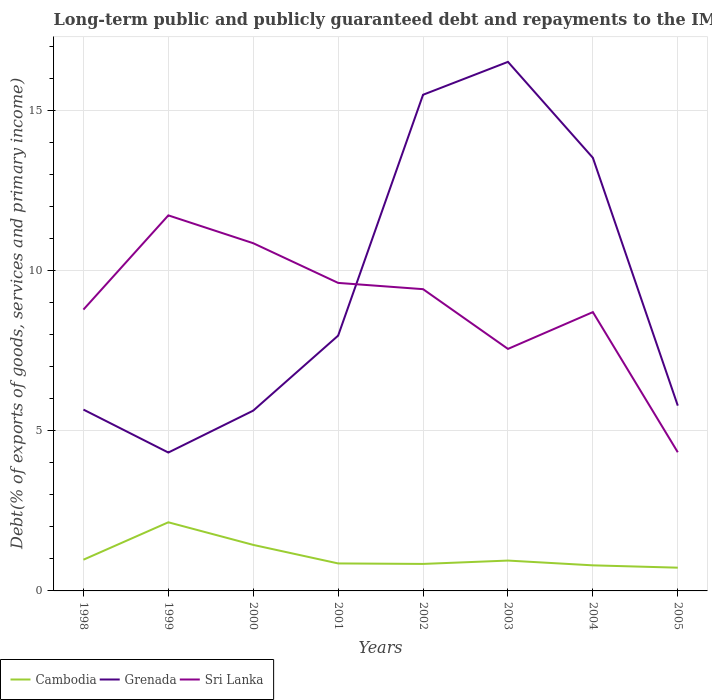Across all years, what is the maximum debt and repayments in Cambodia?
Your response must be concise. 0.73. In which year was the debt and repayments in Cambodia maximum?
Offer a very short reply. 2005. What is the total debt and repayments in Cambodia in the graph?
Provide a succinct answer. 0.13. What is the difference between the highest and the second highest debt and repayments in Grenada?
Provide a short and direct response. 12.19. How many years are there in the graph?
Offer a very short reply. 8. Are the values on the major ticks of Y-axis written in scientific E-notation?
Keep it short and to the point. No. Does the graph contain grids?
Your response must be concise. Yes. Where does the legend appear in the graph?
Your response must be concise. Bottom left. How are the legend labels stacked?
Offer a very short reply. Horizontal. What is the title of the graph?
Your answer should be very brief. Long-term public and publicly guaranteed debt and repayments to the IMF. What is the label or title of the Y-axis?
Provide a short and direct response. Debt(% of exports of goods, services and primary income). What is the Debt(% of exports of goods, services and primary income) of Cambodia in 1998?
Offer a terse response. 0.97. What is the Debt(% of exports of goods, services and primary income) of Grenada in 1998?
Give a very brief answer. 5.66. What is the Debt(% of exports of goods, services and primary income) in Sri Lanka in 1998?
Offer a terse response. 8.78. What is the Debt(% of exports of goods, services and primary income) in Cambodia in 1999?
Your response must be concise. 2.14. What is the Debt(% of exports of goods, services and primary income) in Grenada in 1999?
Your answer should be very brief. 4.32. What is the Debt(% of exports of goods, services and primary income) of Sri Lanka in 1999?
Keep it short and to the point. 11.72. What is the Debt(% of exports of goods, services and primary income) of Cambodia in 2000?
Make the answer very short. 1.44. What is the Debt(% of exports of goods, services and primary income) in Grenada in 2000?
Give a very brief answer. 5.63. What is the Debt(% of exports of goods, services and primary income) of Sri Lanka in 2000?
Provide a succinct answer. 10.85. What is the Debt(% of exports of goods, services and primary income) of Cambodia in 2001?
Offer a very short reply. 0.86. What is the Debt(% of exports of goods, services and primary income) of Grenada in 2001?
Provide a short and direct response. 7.97. What is the Debt(% of exports of goods, services and primary income) of Sri Lanka in 2001?
Your answer should be compact. 9.61. What is the Debt(% of exports of goods, services and primary income) of Cambodia in 2002?
Keep it short and to the point. 0.84. What is the Debt(% of exports of goods, services and primary income) in Grenada in 2002?
Give a very brief answer. 15.49. What is the Debt(% of exports of goods, services and primary income) of Sri Lanka in 2002?
Provide a succinct answer. 9.42. What is the Debt(% of exports of goods, services and primary income) in Cambodia in 2003?
Your answer should be very brief. 0.95. What is the Debt(% of exports of goods, services and primary income) in Grenada in 2003?
Offer a terse response. 16.51. What is the Debt(% of exports of goods, services and primary income) in Sri Lanka in 2003?
Your response must be concise. 7.55. What is the Debt(% of exports of goods, services and primary income) in Cambodia in 2004?
Give a very brief answer. 0.8. What is the Debt(% of exports of goods, services and primary income) of Grenada in 2004?
Provide a succinct answer. 13.52. What is the Debt(% of exports of goods, services and primary income) of Sri Lanka in 2004?
Provide a succinct answer. 8.7. What is the Debt(% of exports of goods, services and primary income) in Cambodia in 2005?
Your response must be concise. 0.73. What is the Debt(% of exports of goods, services and primary income) of Grenada in 2005?
Provide a short and direct response. 5.78. What is the Debt(% of exports of goods, services and primary income) of Sri Lanka in 2005?
Offer a very short reply. 4.33. Across all years, what is the maximum Debt(% of exports of goods, services and primary income) of Cambodia?
Make the answer very short. 2.14. Across all years, what is the maximum Debt(% of exports of goods, services and primary income) of Grenada?
Offer a terse response. 16.51. Across all years, what is the maximum Debt(% of exports of goods, services and primary income) in Sri Lanka?
Offer a terse response. 11.72. Across all years, what is the minimum Debt(% of exports of goods, services and primary income) in Cambodia?
Offer a very short reply. 0.73. Across all years, what is the minimum Debt(% of exports of goods, services and primary income) of Grenada?
Your answer should be very brief. 4.32. Across all years, what is the minimum Debt(% of exports of goods, services and primary income) in Sri Lanka?
Offer a terse response. 4.33. What is the total Debt(% of exports of goods, services and primary income) of Cambodia in the graph?
Provide a succinct answer. 8.72. What is the total Debt(% of exports of goods, services and primary income) in Grenada in the graph?
Make the answer very short. 74.87. What is the total Debt(% of exports of goods, services and primary income) in Sri Lanka in the graph?
Your response must be concise. 70.97. What is the difference between the Debt(% of exports of goods, services and primary income) of Cambodia in 1998 and that in 1999?
Your response must be concise. -1.17. What is the difference between the Debt(% of exports of goods, services and primary income) in Grenada in 1998 and that in 1999?
Provide a succinct answer. 1.34. What is the difference between the Debt(% of exports of goods, services and primary income) of Sri Lanka in 1998 and that in 1999?
Offer a very short reply. -2.94. What is the difference between the Debt(% of exports of goods, services and primary income) of Cambodia in 1998 and that in 2000?
Keep it short and to the point. -0.46. What is the difference between the Debt(% of exports of goods, services and primary income) in Grenada in 1998 and that in 2000?
Keep it short and to the point. 0.03. What is the difference between the Debt(% of exports of goods, services and primary income) of Sri Lanka in 1998 and that in 2000?
Keep it short and to the point. -2.07. What is the difference between the Debt(% of exports of goods, services and primary income) of Cambodia in 1998 and that in 2001?
Give a very brief answer. 0.12. What is the difference between the Debt(% of exports of goods, services and primary income) of Grenada in 1998 and that in 2001?
Give a very brief answer. -2.31. What is the difference between the Debt(% of exports of goods, services and primary income) in Sri Lanka in 1998 and that in 2001?
Your response must be concise. -0.83. What is the difference between the Debt(% of exports of goods, services and primary income) in Cambodia in 1998 and that in 2002?
Your response must be concise. 0.13. What is the difference between the Debt(% of exports of goods, services and primary income) of Grenada in 1998 and that in 2002?
Offer a terse response. -9.83. What is the difference between the Debt(% of exports of goods, services and primary income) of Sri Lanka in 1998 and that in 2002?
Offer a terse response. -0.64. What is the difference between the Debt(% of exports of goods, services and primary income) of Cambodia in 1998 and that in 2003?
Your response must be concise. 0.03. What is the difference between the Debt(% of exports of goods, services and primary income) in Grenada in 1998 and that in 2003?
Provide a short and direct response. -10.85. What is the difference between the Debt(% of exports of goods, services and primary income) of Sri Lanka in 1998 and that in 2003?
Your response must be concise. 1.23. What is the difference between the Debt(% of exports of goods, services and primary income) in Cambodia in 1998 and that in 2004?
Give a very brief answer. 0.18. What is the difference between the Debt(% of exports of goods, services and primary income) in Grenada in 1998 and that in 2004?
Your response must be concise. -7.86. What is the difference between the Debt(% of exports of goods, services and primary income) in Sri Lanka in 1998 and that in 2004?
Provide a short and direct response. 0.08. What is the difference between the Debt(% of exports of goods, services and primary income) in Cambodia in 1998 and that in 2005?
Provide a succinct answer. 0.25. What is the difference between the Debt(% of exports of goods, services and primary income) of Grenada in 1998 and that in 2005?
Your answer should be compact. -0.12. What is the difference between the Debt(% of exports of goods, services and primary income) of Sri Lanka in 1998 and that in 2005?
Provide a short and direct response. 4.45. What is the difference between the Debt(% of exports of goods, services and primary income) in Cambodia in 1999 and that in 2000?
Your answer should be compact. 0.71. What is the difference between the Debt(% of exports of goods, services and primary income) in Grenada in 1999 and that in 2000?
Offer a very short reply. -1.31. What is the difference between the Debt(% of exports of goods, services and primary income) of Sri Lanka in 1999 and that in 2000?
Offer a very short reply. 0.87. What is the difference between the Debt(% of exports of goods, services and primary income) of Cambodia in 1999 and that in 2001?
Keep it short and to the point. 1.28. What is the difference between the Debt(% of exports of goods, services and primary income) in Grenada in 1999 and that in 2001?
Your answer should be very brief. -3.65. What is the difference between the Debt(% of exports of goods, services and primary income) in Sri Lanka in 1999 and that in 2001?
Your answer should be very brief. 2.11. What is the difference between the Debt(% of exports of goods, services and primary income) of Cambodia in 1999 and that in 2002?
Your answer should be compact. 1.3. What is the difference between the Debt(% of exports of goods, services and primary income) in Grenada in 1999 and that in 2002?
Your answer should be very brief. -11.17. What is the difference between the Debt(% of exports of goods, services and primary income) in Sri Lanka in 1999 and that in 2002?
Ensure brevity in your answer.  2.3. What is the difference between the Debt(% of exports of goods, services and primary income) in Cambodia in 1999 and that in 2003?
Keep it short and to the point. 1.19. What is the difference between the Debt(% of exports of goods, services and primary income) in Grenada in 1999 and that in 2003?
Your response must be concise. -12.19. What is the difference between the Debt(% of exports of goods, services and primary income) in Sri Lanka in 1999 and that in 2003?
Provide a succinct answer. 4.17. What is the difference between the Debt(% of exports of goods, services and primary income) of Cambodia in 1999 and that in 2004?
Make the answer very short. 1.34. What is the difference between the Debt(% of exports of goods, services and primary income) in Grenada in 1999 and that in 2004?
Provide a short and direct response. -9.2. What is the difference between the Debt(% of exports of goods, services and primary income) of Sri Lanka in 1999 and that in 2004?
Ensure brevity in your answer.  3.02. What is the difference between the Debt(% of exports of goods, services and primary income) in Cambodia in 1999 and that in 2005?
Keep it short and to the point. 1.42. What is the difference between the Debt(% of exports of goods, services and primary income) in Grenada in 1999 and that in 2005?
Offer a terse response. -1.46. What is the difference between the Debt(% of exports of goods, services and primary income) of Sri Lanka in 1999 and that in 2005?
Offer a terse response. 7.39. What is the difference between the Debt(% of exports of goods, services and primary income) in Cambodia in 2000 and that in 2001?
Provide a short and direct response. 0.58. What is the difference between the Debt(% of exports of goods, services and primary income) of Grenada in 2000 and that in 2001?
Ensure brevity in your answer.  -2.34. What is the difference between the Debt(% of exports of goods, services and primary income) in Sri Lanka in 2000 and that in 2001?
Give a very brief answer. 1.24. What is the difference between the Debt(% of exports of goods, services and primary income) of Cambodia in 2000 and that in 2002?
Provide a short and direct response. 0.59. What is the difference between the Debt(% of exports of goods, services and primary income) of Grenada in 2000 and that in 2002?
Offer a terse response. -9.86. What is the difference between the Debt(% of exports of goods, services and primary income) of Sri Lanka in 2000 and that in 2002?
Your answer should be compact. 1.43. What is the difference between the Debt(% of exports of goods, services and primary income) in Cambodia in 2000 and that in 2003?
Ensure brevity in your answer.  0.49. What is the difference between the Debt(% of exports of goods, services and primary income) in Grenada in 2000 and that in 2003?
Your answer should be very brief. -10.88. What is the difference between the Debt(% of exports of goods, services and primary income) of Sri Lanka in 2000 and that in 2003?
Make the answer very short. 3.3. What is the difference between the Debt(% of exports of goods, services and primary income) in Cambodia in 2000 and that in 2004?
Your response must be concise. 0.64. What is the difference between the Debt(% of exports of goods, services and primary income) of Grenada in 2000 and that in 2004?
Make the answer very short. -7.89. What is the difference between the Debt(% of exports of goods, services and primary income) in Sri Lanka in 2000 and that in 2004?
Ensure brevity in your answer.  2.15. What is the difference between the Debt(% of exports of goods, services and primary income) in Cambodia in 2000 and that in 2005?
Provide a short and direct response. 0.71. What is the difference between the Debt(% of exports of goods, services and primary income) of Grenada in 2000 and that in 2005?
Offer a terse response. -0.16. What is the difference between the Debt(% of exports of goods, services and primary income) of Sri Lanka in 2000 and that in 2005?
Offer a very short reply. 6.52. What is the difference between the Debt(% of exports of goods, services and primary income) of Cambodia in 2001 and that in 2002?
Provide a succinct answer. 0.02. What is the difference between the Debt(% of exports of goods, services and primary income) of Grenada in 2001 and that in 2002?
Your answer should be very brief. -7.52. What is the difference between the Debt(% of exports of goods, services and primary income) in Sri Lanka in 2001 and that in 2002?
Your response must be concise. 0.2. What is the difference between the Debt(% of exports of goods, services and primary income) in Cambodia in 2001 and that in 2003?
Your answer should be very brief. -0.09. What is the difference between the Debt(% of exports of goods, services and primary income) of Grenada in 2001 and that in 2003?
Your answer should be compact. -8.54. What is the difference between the Debt(% of exports of goods, services and primary income) in Sri Lanka in 2001 and that in 2003?
Keep it short and to the point. 2.06. What is the difference between the Debt(% of exports of goods, services and primary income) in Cambodia in 2001 and that in 2004?
Your response must be concise. 0.06. What is the difference between the Debt(% of exports of goods, services and primary income) of Grenada in 2001 and that in 2004?
Offer a very short reply. -5.55. What is the difference between the Debt(% of exports of goods, services and primary income) of Sri Lanka in 2001 and that in 2004?
Make the answer very short. 0.91. What is the difference between the Debt(% of exports of goods, services and primary income) in Cambodia in 2001 and that in 2005?
Your answer should be compact. 0.13. What is the difference between the Debt(% of exports of goods, services and primary income) of Grenada in 2001 and that in 2005?
Offer a terse response. 2.19. What is the difference between the Debt(% of exports of goods, services and primary income) in Sri Lanka in 2001 and that in 2005?
Provide a succinct answer. 5.29. What is the difference between the Debt(% of exports of goods, services and primary income) of Cambodia in 2002 and that in 2003?
Keep it short and to the point. -0.1. What is the difference between the Debt(% of exports of goods, services and primary income) in Grenada in 2002 and that in 2003?
Your answer should be very brief. -1.03. What is the difference between the Debt(% of exports of goods, services and primary income) in Sri Lanka in 2002 and that in 2003?
Ensure brevity in your answer.  1.86. What is the difference between the Debt(% of exports of goods, services and primary income) in Cambodia in 2002 and that in 2004?
Provide a succinct answer. 0.04. What is the difference between the Debt(% of exports of goods, services and primary income) of Grenada in 2002 and that in 2004?
Offer a very short reply. 1.97. What is the difference between the Debt(% of exports of goods, services and primary income) of Sri Lanka in 2002 and that in 2004?
Provide a short and direct response. 0.72. What is the difference between the Debt(% of exports of goods, services and primary income) in Cambodia in 2002 and that in 2005?
Offer a very short reply. 0.12. What is the difference between the Debt(% of exports of goods, services and primary income) in Grenada in 2002 and that in 2005?
Ensure brevity in your answer.  9.7. What is the difference between the Debt(% of exports of goods, services and primary income) in Sri Lanka in 2002 and that in 2005?
Your answer should be compact. 5.09. What is the difference between the Debt(% of exports of goods, services and primary income) in Cambodia in 2003 and that in 2004?
Your answer should be compact. 0.15. What is the difference between the Debt(% of exports of goods, services and primary income) in Grenada in 2003 and that in 2004?
Give a very brief answer. 2.99. What is the difference between the Debt(% of exports of goods, services and primary income) of Sri Lanka in 2003 and that in 2004?
Make the answer very short. -1.15. What is the difference between the Debt(% of exports of goods, services and primary income) of Cambodia in 2003 and that in 2005?
Offer a terse response. 0.22. What is the difference between the Debt(% of exports of goods, services and primary income) in Grenada in 2003 and that in 2005?
Your answer should be very brief. 10.73. What is the difference between the Debt(% of exports of goods, services and primary income) of Sri Lanka in 2003 and that in 2005?
Offer a very short reply. 3.23. What is the difference between the Debt(% of exports of goods, services and primary income) in Cambodia in 2004 and that in 2005?
Make the answer very short. 0.07. What is the difference between the Debt(% of exports of goods, services and primary income) in Grenada in 2004 and that in 2005?
Ensure brevity in your answer.  7.74. What is the difference between the Debt(% of exports of goods, services and primary income) in Sri Lanka in 2004 and that in 2005?
Your answer should be very brief. 4.37. What is the difference between the Debt(% of exports of goods, services and primary income) in Cambodia in 1998 and the Debt(% of exports of goods, services and primary income) in Grenada in 1999?
Provide a short and direct response. -3.34. What is the difference between the Debt(% of exports of goods, services and primary income) of Cambodia in 1998 and the Debt(% of exports of goods, services and primary income) of Sri Lanka in 1999?
Make the answer very short. -10.75. What is the difference between the Debt(% of exports of goods, services and primary income) in Grenada in 1998 and the Debt(% of exports of goods, services and primary income) in Sri Lanka in 1999?
Keep it short and to the point. -6.06. What is the difference between the Debt(% of exports of goods, services and primary income) in Cambodia in 1998 and the Debt(% of exports of goods, services and primary income) in Grenada in 2000?
Your response must be concise. -4.65. What is the difference between the Debt(% of exports of goods, services and primary income) in Cambodia in 1998 and the Debt(% of exports of goods, services and primary income) in Sri Lanka in 2000?
Offer a terse response. -9.88. What is the difference between the Debt(% of exports of goods, services and primary income) of Grenada in 1998 and the Debt(% of exports of goods, services and primary income) of Sri Lanka in 2000?
Offer a very short reply. -5.19. What is the difference between the Debt(% of exports of goods, services and primary income) of Cambodia in 1998 and the Debt(% of exports of goods, services and primary income) of Grenada in 2001?
Provide a succinct answer. -6.99. What is the difference between the Debt(% of exports of goods, services and primary income) in Cambodia in 1998 and the Debt(% of exports of goods, services and primary income) in Sri Lanka in 2001?
Make the answer very short. -8.64. What is the difference between the Debt(% of exports of goods, services and primary income) of Grenada in 1998 and the Debt(% of exports of goods, services and primary income) of Sri Lanka in 2001?
Offer a very short reply. -3.95. What is the difference between the Debt(% of exports of goods, services and primary income) of Cambodia in 1998 and the Debt(% of exports of goods, services and primary income) of Grenada in 2002?
Offer a very short reply. -14.51. What is the difference between the Debt(% of exports of goods, services and primary income) in Cambodia in 1998 and the Debt(% of exports of goods, services and primary income) in Sri Lanka in 2002?
Your answer should be compact. -8.44. What is the difference between the Debt(% of exports of goods, services and primary income) in Grenada in 1998 and the Debt(% of exports of goods, services and primary income) in Sri Lanka in 2002?
Keep it short and to the point. -3.76. What is the difference between the Debt(% of exports of goods, services and primary income) in Cambodia in 1998 and the Debt(% of exports of goods, services and primary income) in Grenada in 2003?
Offer a terse response. -15.54. What is the difference between the Debt(% of exports of goods, services and primary income) in Cambodia in 1998 and the Debt(% of exports of goods, services and primary income) in Sri Lanka in 2003?
Keep it short and to the point. -6.58. What is the difference between the Debt(% of exports of goods, services and primary income) of Grenada in 1998 and the Debt(% of exports of goods, services and primary income) of Sri Lanka in 2003?
Provide a succinct answer. -1.89. What is the difference between the Debt(% of exports of goods, services and primary income) in Cambodia in 1998 and the Debt(% of exports of goods, services and primary income) in Grenada in 2004?
Your answer should be compact. -12.54. What is the difference between the Debt(% of exports of goods, services and primary income) in Cambodia in 1998 and the Debt(% of exports of goods, services and primary income) in Sri Lanka in 2004?
Your answer should be very brief. -7.73. What is the difference between the Debt(% of exports of goods, services and primary income) of Grenada in 1998 and the Debt(% of exports of goods, services and primary income) of Sri Lanka in 2004?
Your answer should be very brief. -3.04. What is the difference between the Debt(% of exports of goods, services and primary income) in Cambodia in 1998 and the Debt(% of exports of goods, services and primary income) in Grenada in 2005?
Your answer should be compact. -4.81. What is the difference between the Debt(% of exports of goods, services and primary income) of Cambodia in 1998 and the Debt(% of exports of goods, services and primary income) of Sri Lanka in 2005?
Your answer should be very brief. -3.35. What is the difference between the Debt(% of exports of goods, services and primary income) of Grenada in 1998 and the Debt(% of exports of goods, services and primary income) of Sri Lanka in 2005?
Your answer should be compact. 1.33. What is the difference between the Debt(% of exports of goods, services and primary income) in Cambodia in 1999 and the Debt(% of exports of goods, services and primary income) in Grenada in 2000?
Make the answer very short. -3.49. What is the difference between the Debt(% of exports of goods, services and primary income) of Cambodia in 1999 and the Debt(% of exports of goods, services and primary income) of Sri Lanka in 2000?
Provide a short and direct response. -8.71. What is the difference between the Debt(% of exports of goods, services and primary income) in Grenada in 1999 and the Debt(% of exports of goods, services and primary income) in Sri Lanka in 2000?
Ensure brevity in your answer.  -6.53. What is the difference between the Debt(% of exports of goods, services and primary income) in Cambodia in 1999 and the Debt(% of exports of goods, services and primary income) in Grenada in 2001?
Your response must be concise. -5.83. What is the difference between the Debt(% of exports of goods, services and primary income) of Cambodia in 1999 and the Debt(% of exports of goods, services and primary income) of Sri Lanka in 2001?
Ensure brevity in your answer.  -7.47. What is the difference between the Debt(% of exports of goods, services and primary income) of Grenada in 1999 and the Debt(% of exports of goods, services and primary income) of Sri Lanka in 2001?
Give a very brief answer. -5.29. What is the difference between the Debt(% of exports of goods, services and primary income) of Cambodia in 1999 and the Debt(% of exports of goods, services and primary income) of Grenada in 2002?
Your answer should be very brief. -13.34. What is the difference between the Debt(% of exports of goods, services and primary income) in Cambodia in 1999 and the Debt(% of exports of goods, services and primary income) in Sri Lanka in 2002?
Make the answer very short. -7.28. What is the difference between the Debt(% of exports of goods, services and primary income) of Grenada in 1999 and the Debt(% of exports of goods, services and primary income) of Sri Lanka in 2002?
Offer a terse response. -5.1. What is the difference between the Debt(% of exports of goods, services and primary income) in Cambodia in 1999 and the Debt(% of exports of goods, services and primary income) in Grenada in 2003?
Offer a terse response. -14.37. What is the difference between the Debt(% of exports of goods, services and primary income) in Cambodia in 1999 and the Debt(% of exports of goods, services and primary income) in Sri Lanka in 2003?
Your answer should be very brief. -5.41. What is the difference between the Debt(% of exports of goods, services and primary income) of Grenada in 1999 and the Debt(% of exports of goods, services and primary income) of Sri Lanka in 2003?
Make the answer very short. -3.23. What is the difference between the Debt(% of exports of goods, services and primary income) of Cambodia in 1999 and the Debt(% of exports of goods, services and primary income) of Grenada in 2004?
Give a very brief answer. -11.38. What is the difference between the Debt(% of exports of goods, services and primary income) of Cambodia in 1999 and the Debt(% of exports of goods, services and primary income) of Sri Lanka in 2004?
Your response must be concise. -6.56. What is the difference between the Debt(% of exports of goods, services and primary income) in Grenada in 1999 and the Debt(% of exports of goods, services and primary income) in Sri Lanka in 2004?
Your answer should be very brief. -4.38. What is the difference between the Debt(% of exports of goods, services and primary income) in Cambodia in 1999 and the Debt(% of exports of goods, services and primary income) in Grenada in 2005?
Give a very brief answer. -3.64. What is the difference between the Debt(% of exports of goods, services and primary income) in Cambodia in 1999 and the Debt(% of exports of goods, services and primary income) in Sri Lanka in 2005?
Your answer should be very brief. -2.19. What is the difference between the Debt(% of exports of goods, services and primary income) of Grenada in 1999 and the Debt(% of exports of goods, services and primary income) of Sri Lanka in 2005?
Give a very brief answer. -0.01. What is the difference between the Debt(% of exports of goods, services and primary income) in Cambodia in 2000 and the Debt(% of exports of goods, services and primary income) in Grenada in 2001?
Provide a short and direct response. -6.53. What is the difference between the Debt(% of exports of goods, services and primary income) in Cambodia in 2000 and the Debt(% of exports of goods, services and primary income) in Sri Lanka in 2001?
Your response must be concise. -8.18. What is the difference between the Debt(% of exports of goods, services and primary income) in Grenada in 2000 and the Debt(% of exports of goods, services and primary income) in Sri Lanka in 2001?
Offer a terse response. -3.99. What is the difference between the Debt(% of exports of goods, services and primary income) in Cambodia in 2000 and the Debt(% of exports of goods, services and primary income) in Grenada in 2002?
Offer a very short reply. -14.05. What is the difference between the Debt(% of exports of goods, services and primary income) of Cambodia in 2000 and the Debt(% of exports of goods, services and primary income) of Sri Lanka in 2002?
Your response must be concise. -7.98. What is the difference between the Debt(% of exports of goods, services and primary income) of Grenada in 2000 and the Debt(% of exports of goods, services and primary income) of Sri Lanka in 2002?
Your answer should be compact. -3.79. What is the difference between the Debt(% of exports of goods, services and primary income) in Cambodia in 2000 and the Debt(% of exports of goods, services and primary income) in Grenada in 2003?
Make the answer very short. -15.08. What is the difference between the Debt(% of exports of goods, services and primary income) in Cambodia in 2000 and the Debt(% of exports of goods, services and primary income) in Sri Lanka in 2003?
Offer a terse response. -6.12. What is the difference between the Debt(% of exports of goods, services and primary income) of Grenada in 2000 and the Debt(% of exports of goods, services and primary income) of Sri Lanka in 2003?
Your answer should be compact. -1.93. What is the difference between the Debt(% of exports of goods, services and primary income) of Cambodia in 2000 and the Debt(% of exports of goods, services and primary income) of Grenada in 2004?
Provide a short and direct response. -12.08. What is the difference between the Debt(% of exports of goods, services and primary income) in Cambodia in 2000 and the Debt(% of exports of goods, services and primary income) in Sri Lanka in 2004?
Keep it short and to the point. -7.27. What is the difference between the Debt(% of exports of goods, services and primary income) of Grenada in 2000 and the Debt(% of exports of goods, services and primary income) of Sri Lanka in 2004?
Offer a very short reply. -3.07. What is the difference between the Debt(% of exports of goods, services and primary income) in Cambodia in 2000 and the Debt(% of exports of goods, services and primary income) in Grenada in 2005?
Keep it short and to the point. -4.35. What is the difference between the Debt(% of exports of goods, services and primary income) of Cambodia in 2000 and the Debt(% of exports of goods, services and primary income) of Sri Lanka in 2005?
Offer a very short reply. -2.89. What is the difference between the Debt(% of exports of goods, services and primary income) in Grenada in 2000 and the Debt(% of exports of goods, services and primary income) in Sri Lanka in 2005?
Your answer should be compact. 1.3. What is the difference between the Debt(% of exports of goods, services and primary income) in Cambodia in 2001 and the Debt(% of exports of goods, services and primary income) in Grenada in 2002?
Offer a terse response. -14.63. What is the difference between the Debt(% of exports of goods, services and primary income) of Cambodia in 2001 and the Debt(% of exports of goods, services and primary income) of Sri Lanka in 2002?
Offer a terse response. -8.56. What is the difference between the Debt(% of exports of goods, services and primary income) of Grenada in 2001 and the Debt(% of exports of goods, services and primary income) of Sri Lanka in 2002?
Provide a short and direct response. -1.45. What is the difference between the Debt(% of exports of goods, services and primary income) in Cambodia in 2001 and the Debt(% of exports of goods, services and primary income) in Grenada in 2003?
Offer a terse response. -15.65. What is the difference between the Debt(% of exports of goods, services and primary income) in Cambodia in 2001 and the Debt(% of exports of goods, services and primary income) in Sri Lanka in 2003?
Give a very brief answer. -6.7. What is the difference between the Debt(% of exports of goods, services and primary income) in Grenada in 2001 and the Debt(% of exports of goods, services and primary income) in Sri Lanka in 2003?
Keep it short and to the point. 0.41. What is the difference between the Debt(% of exports of goods, services and primary income) in Cambodia in 2001 and the Debt(% of exports of goods, services and primary income) in Grenada in 2004?
Offer a terse response. -12.66. What is the difference between the Debt(% of exports of goods, services and primary income) in Cambodia in 2001 and the Debt(% of exports of goods, services and primary income) in Sri Lanka in 2004?
Your answer should be compact. -7.84. What is the difference between the Debt(% of exports of goods, services and primary income) of Grenada in 2001 and the Debt(% of exports of goods, services and primary income) of Sri Lanka in 2004?
Make the answer very short. -0.73. What is the difference between the Debt(% of exports of goods, services and primary income) of Cambodia in 2001 and the Debt(% of exports of goods, services and primary income) of Grenada in 2005?
Your answer should be very brief. -4.92. What is the difference between the Debt(% of exports of goods, services and primary income) of Cambodia in 2001 and the Debt(% of exports of goods, services and primary income) of Sri Lanka in 2005?
Make the answer very short. -3.47. What is the difference between the Debt(% of exports of goods, services and primary income) in Grenada in 2001 and the Debt(% of exports of goods, services and primary income) in Sri Lanka in 2005?
Provide a short and direct response. 3.64. What is the difference between the Debt(% of exports of goods, services and primary income) in Cambodia in 2002 and the Debt(% of exports of goods, services and primary income) in Grenada in 2003?
Offer a very short reply. -15.67. What is the difference between the Debt(% of exports of goods, services and primary income) in Cambodia in 2002 and the Debt(% of exports of goods, services and primary income) in Sri Lanka in 2003?
Keep it short and to the point. -6.71. What is the difference between the Debt(% of exports of goods, services and primary income) in Grenada in 2002 and the Debt(% of exports of goods, services and primary income) in Sri Lanka in 2003?
Make the answer very short. 7.93. What is the difference between the Debt(% of exports of goods, services and primary income) of Cambodia in 2002 and the Debt(% of exports of goods, services and primary income) of Grenada in 2004?
Give a very brief answer. -12.68. What is the difference between the Debt(% of exports of goods, services and primary income) in Cambodia in 2002 and the Debt(% of exports of goods, services and primary income) in Sri Lanka in 2004?
Your answer should be compact. -7.86. What is the difference between the Debt(% of exports of goods, services and primary income) in Grenada in 2002 and the Debt(% of exports of goods, services and primary income) in Sri Lanka in 2004?
Offer a terse response. 6.78. What is the difference between the Debt(% of exports of goods, services and primary income) of Cambodia in 2002 and the Debt(% of exports of goods, services and primary income) of Grenada in 2005?
Your response must be concise. -4.94. What is the difference between the Debt(% of exports of goods, services and primary income) of Cambodia in 2002 and the Debt(% of exports of goods, services and primary income) of Sri Lanka in 2005?
Provide a succinct answer. -3.49. What is the difference between the Debt(% of exports of goods, services and primary income) in Grenada in 2002 and the Debt(% of exports of goods, services and primary income) in Sri Lanka in 2005?
Make the answer very short. 11.16. What is the difference between the Debt(% of exports of goods, services and primary income) in Cambodia in 2003 and the Debt(% of exports of goods, services and primary income) in Grenada in 2004?
Provide a succinct answer. -12.57. What is the difference between the Debt(% of exports of goods, services and primary income) of Cambodia in 2003 and the Debt(% of exports of goods, services and primary income) of Sri Lanka in 2004?
Make the answer very short. -7.75. What is the difference between the Debt(% of exports of goods, services and primary income) of Grenada in 2003 and the Debt(% of exports of goods, services and primary income) of Sri Lanka in 2004?
Keep it short and to the point. 7.81. What is the difference between the Debt(% of exports of goods, services and primary income) in Cambodia in 2003 and the Debt(% of exports of goods, services and primary income) in Grenada in 2005?
Make the answer very short. -4.84. What is the difference between the Debt(% of exports of goods, services and primary income) in Cambodia in 2003 and the Debt(% of exports of goods, services and primary income) in Sri Lanka in 2005?
Your answer should be compact. -3.38. What is the difference between the Debt(% of exports of goods, services and primary income) in Grenada in 2003 and the Debt(% of exports of goods, services and primary income) in Sri Lanka in 2005?
Provide a short and direct response. 12.18. What is the difference between the Debt(% of exports of goods, services and primary income) in Cambodia in 2004 and the Debt(% of exports of goods, services and primary income) in Grenada in 2005?
Make the answer very short. -4.98. What is the difference between the Debt(% of exports of goods, services and primary income) in Cambodia in 2004 and the Debt(% of exports of goods, services and primary income) in Sri Lanka in 2005?
Keep it short and to the point. -3.53. What is the difference between the Debt(% of exports of goods, services and primary income) of Grenada in 2004 and the Debt(% of exports of goods, services and primary income) of Sri Lanka in 2005?
Ensure brevity in your answer.  9.19. What is the average Debt(% of exports of goods, services and primary income) of Cambodia per year?
Keep it short and to the point. 1.09. What is the average Debt(% of exports of goods, services and primary income) in Grenada per year?
Offer a very short reply. 9.36. What is the average Debt(% of exports of goods, services and primary income) of Sri Lanka per year?
Offer a terse response. 8.87. In the year 1998, what is the difference between the Debt(% of exports of goods, services and primary income) of Cambodia and Debt(% of exports of goods, services and primary income) of Grenada?
Your answer should be compact. -4.69. In the year 1998, what is the difference between the Debt(% of exports of goods, services and primary income) in Cambodia and Debt(% of exports of goods, services and primary income) in Sri Lanka?
Your response must be concise. -7.81. In the year 1998, what is the difference between the Debt(% of exports of goods, services and primary income) in Grenada and Debt(% of exports of goods, services and primary income) in Sri Lanka?
Ensure brevity in your answer.  -3.12. In the year 1999, what is the difference between the Debt(% of exports of goods, services and primary income) of Cambodia and Debt(% of exports of goods, services and primary income) of Grenada?
Give a very brief answer. -2.18. In the year 1999, what is the difference between the Debt(% of exports of goods, services and primary income) in Cambodia and Debt(% of exports of goods, services and primary income) in Sri Lanka?
Provide a succinct answer. -9.58. In the year 1999, what is the difference between the Debt(% of exports of goods, services and primary income) of Grenada and Debt(% of exports of goods, services and primary income) of Sri Lanka?
Your response must be concise. -7.4. In the year 2000, what is the difference between the Debt(% of exports of goods, services and primary income) of Cambodia and Debt(% of exports of goods, services and primary income) of Grenada?
Your answer should be compact. -4.19. In the year 2000, what is the difference between the Debt(% of exports of goods, services and primary income) of Cambodia and Debt(% of exports of goods, services and primary income) of Sri Lanka?
Ensure brevity in your answer.  -9.42. In the year 2000, what is the difference between the Debt(% of exports of goods, services and primary income) in Grenada and Debt(% of exports of goods, services and primary income) in Sri Lanka?
Ensure brevity in your answer.  -5.22. In the year 2001, what is the difference between the Debt(% of exports of goods, services and primary income) of Cambodia and Debt(% of exports of goods, services and primary income) of Grenada?
Offer a terse response. -7.11. In the year 2001, what is the difference between the Debt(% of exports of goods, services and primary income) in Cambodia and Debt(% of exports of goods, services and primary income) in Sri Lanka?
Offer a terse response. -8.76. In the year 2001, what is the difference between the Debt(% of exports of goods, services and primary income) in Grenada and Debt(% of exports of goods, services and primary income) in Sri Lanka?
Your response must be concise. -1.65. In the year 2002, what is the difference between the Debt(% of exports of goods, services and primary income) of Cambodia and Debt(% of exports of goods, services and primary income) of Grenada?
Your answer should be compact. -14.64. In the year 2002, what is the difference between the Debt(% of exports of goods, services and primary income) in Cambodia and Debt(% of exports of goods, services and primary income) in Sri Lanka?
Provide a succinct answer. -8.58. In the year 2002, what is the difference between the Debt(% of exports of goods, services and primary income) in Grenada and Debt(% of exports of goods, services and primary income) in Sri Lanka?
Ensure brevity in your answer.  6.07. In the year 2003, what is the difference between the Debt(% of exports of goods, services and primary income) of Cambodia and Debt(% of exports of goods, services and primary income) of Grenada?
Keep it short and to the point. -15.56. In the year 2003, what is the difference between the Debt(% of exports of goods, services and primary income) of Cambodia and Debt(% of exports of goods, services and primary income) of Sri Lanka?
Provide a succinct answer. -6.61. In the year 2003, what is the difference between the Debt(% of exports of goods, services and primary income) of Grenada and Debt(% of exports of goods, services and primary income) of Sri Lanka?
Offer a very short reply. 8.96. In the year 2004, what is the difference between the Debt(% of exports of goods, services and primary income) of Cambodia and Debt(% of exports of goods, services and primary income) of Grenada?
Ensure brevity in your answer.  -12.72. In the year 2004, what is the difference between the Debt(% of exports of goods, services and primary income) in Cambodia and Debt(% of exports of goods, services and primary income) in Sri Lanka?
Your answer should be compact. -7.9. In the year 2004, what is the difference between the Debt(% of exports of goods, services and primary income) in Grenada and Debt(% of exports of goods, services and primary income) in Sri Lanka?
Offer a terse response. 4.82. In the year 2005, what is the difference between the Debt(% of exports of goods, services and primary income) in Cambodia and Debt(% of exports of goods, services and primary income) in Grenada?
Ensure brevity in your answer.  -5.06. In the year 2005, what is the difference between the Debt(% of exports of goods, services and primary income) in Cambodia and Debt(% of exports of goods, services and primary income) in Sri Lanka?
Offer a terse response. -3.6. In the year 2005, what is the difference between the Debt(% of exports of goods, services and primary income) of Grenada and Debt(% of exports of goods, services and primary income) of Sri Lanka?
Ensure brevity in your answer.  1.46. What is the ratio of the Debt(% of exports of goods, services and primary income) of Cambodia in 1998 to that in 1999?
Give a very brief answer. 0.45. What is the ratio of the Debt(% of exports of goods, services and primary income) of Grenada in 1998 to that in 1999?
Make the answer very short. 1.31. What is the ratio of the Debt(% of exports of goods, services and primary income) of Sri Lanka in 1998 to that in 1999?
Keep it short and to the point. 0.75. What is the ratio of the Debt(% of exports of goods, services and primary income) in Cambodia in 1998 to that in 2000?
Your answer should be very brief. 0.68. What is the ratio of the Debt(% of exports of goods, services and primary income) in Grenada in 1998 to that in 2000?
Your answer should be compact. 1.01. What is the ratio of the Debt(% of exports of goods, services and primary income) in Sri Lanka in 1998 to that in 2000?
Provide a succinct answer. 0.81. What is the ratio of the Debt(% of exports of goods, services and primary income) of Cambodia in 1998 to that in 2001?
Your answer should be very brief. 1.14. What is the ratio of the Debt(% of exports of goods, services and primary income) in Grenada in 1998 to that in 2001?
Ensure brevity in your answer.  0.71. What is the ratio of the Debt(% of exports of goods, services and primary income) of Sri Lanka in 1998 to that in 2001?
Offer a very short reply. 0.91. What is the ratio of the Debt(% of exports of goods, services and primary income) in Cambodia in 1998 to that in 2002?
Your answer should be compact. 1.16. What is the ratio of the Debt(% of exports of goods, services and primary income) of Grenada in 1998 to that in 2002?
Provide a short and direct response. 0.37. What is the ratio of the Debt(% of exports of goods, services and primary income) of Sri Lanka in 1998 to that in 2002?
Give a very brief answer. 0.93. What is the ratio of the Debt(% of exports of goods, services and primary income) of Cambodia in 1998 to that in 2003?
Offer a very short reply. 1.03. What is the ratio of the Debt(% of exports of goods, services and primary income) in Grenada in 1998 to that in 2003?
Give a very brief answer. 0.34. What is the ratio of the Debt(% of exports of goods, services and primary income) in Sri Lanka in 1998 to that in 2003?
Your answer should be very brief. 1.16. What is the ratio of the Debt(% of exports of goods, services and primary income) of Cambodia in 1998 to that in 2004?
Give a very brief answer. 1.22. What is the ratio of the Debt(% of exports of goods, services and primary income) in Grenada in 1998 to that in 2004?
Ensure brevity in your answer.  0.42. What is the ratio of the Debt(% of exports of goods, services and primary income) of Sri Lanka in 1998 to that in 2004?
Ensure brevity in your answer.  1.01. What is the ratio of the Debt(% of exports of goods, services and primary income) in Cambodia in 1998 to that in 2005?
Your response must be concise. 1.34. What is the ratio of the Debt(% of exports of goods, services and primary income) of Grenada in 1998 to that in 2005?
Provide a succinct answer. 0.98. What is the ratio of the Debt(% of exports of goods, services and primary income) of Sri Lanka in 1998 to that in 2005?
Make the answer very short. 2.03. What is the ratio of the Debt(% of exports of goods, services and primary income) in Cambodia in 1999 to that in 2000?
Your response must be concise. 1.49. What is the ratio of the Debt(% of exports of goods, services and primary income) in Grenada in 1999 to that in 2000?
Keep it short and to the point. 0.77. What is the ratio of the Debt(% of exports of goods, services and primary income) in Sri Lanka in 1999 to that in 2000?
Keep it short and to the point. 1.08. What is the ratio of the Debt(% of exports of goods, services and primary income) of Cambodia in 1999 to that in 2001?
Your answer should be compact. 2.5. What is the ratio of the Debt(% of exports of goods, services and primary income) in Grenada in 1999 to that in 2001?
Ensure brevity in your answer.  0.54. What is the ratio of the Debt(% of exports of goods, services and primary income) of Sri Lanka in 1999 to that in 2001?
Keep it short and to the point. 1.22. What is the ratio of the Debt(% of exports of goods, services and primary income) in Cambodia in 1999 to that in 2002?
Make the answer very short. 2.54. What is the ratio of the Debt(% of exports of goods, services and primary income) in Grenada in 1999 to that in 2002?
Your answer should be very brief. 0.28. What is the ratio of the Debt(% of exports of goods, services and primary income) in Sri Lanka in 1999 to that in 2002?
Give a very brief answer. 1.24. What is the ratio of the Debt(% of exports of goods, services and primary income) in Cambodia in 1999 to that in 2003?
Ensure brevity in your answer.  2.26. What is the ratio of the Debt(% of exports of goods, services and primary income) in Grenada in 1999 to that in 2003?
Offer a terse response. 0.26. What is the ratio of the Debt(% of exports of goods, services and primary income) of Sri Lanka in 1999 to that in 2003?
Give a very brief answer. 1.55. What is the ratio of the Debt(% of exports of goods, services and primary income) of Cambodia in 1999 to that in 2004?
Offer a very short reply. 2.68. What is the ratio of the Debt(% of exports of goods, services and primary income) of Grenada in 1999 to that in 2004?
Your response must be concise. 0.32. What is the ratio of the Debt(% of exports of goods, services and primary income) in Sri Lanka in 1999 to that in 2004?
Give a very brief answer. 1.35. What is the ratio of the Debt(% of exports of goods, services and primary income) of Cambodia in 1999 to that in 2005?
Keep it short and to the point. 2.95. What is the ratio of the Debt(% of exports of goods, services and primary income) of Grenada in 1999 to that in 2005?
Make the answer very short. 0.75. What is the ratio of the Debt(% of exports of goods, services and primary income) of Sri Lanka in 1999 to that in 2005?
Provide a short and direct response. 2.71. What is the ratio of the Debt(% of exports of goods, services and primary income) in Cambodia in 2000 to that in 2001?
Offer a very short reply. 1.67. What is the ratio of the Debt(% of exports of goods, services and primary income) in Grenada in 2000 to that in 2001?
Keep it short and to the point. 0.71. What is the ratio of the Debt(% of exports of goods, services and primary income) in Sri Lanka in 2000 to that in 2001?
Your response must be concise. 1.13. What is the ratio of the Debt(% of exports of goods, services and primary income) in Cambodia in 2000 to that in 2002?
Ensure brevity in your answer.  1.7. What is the ratio of the Debt(% of exports of goods, services and primary income) of Grenada in 2000 to that in 2002?
Ensure brevity in your answer.  0.36. What is the ratio of the Debt(% of exports of goods, services and primary income) in Sri Lanka in 2000 to that in 2002?
Your answer should be compact. 1.15. What is the ratio of the Debt(% of exports of goods, services and primary income) of Cambodia in 2000 to that in 2003?
Provide a succinct answer. 1.52. What is the ratio of the Debt(% of exports of goods, services and primary income) of Grenada in 2000 to that in 2003?
Provide a succinct answer. 0.34. What is the ratio of the Debt(% of exports of goods, services and primary income) of Sri Lanka in 2000 to that in 2003?
Your answer should be compact. 1.44. What is the ratio of the Debt(% of exports of goods, services and primary income) of Cambodia in 2000 to that in 2004?
Offer a very short reply. 1.8. What is the ratio of the Debt(% of exports of goods, services and primary income) in Grenada in 2000 to that in 2004?
Offer a terse response. 0.42. What is the ratio of the Debt(% of exports of goods, services and primary income) of Sri Lanka in 2000 to that in 2004?
Offer a terse response. 1.25. What is the ratio of the Debt(% of exports of goods, services and primary income) in Cambodia in 2000 to that in 2005?
Your response must be concise. 1.98. What is the ratio of the Debt(% of exports of goods, services and primary income) of Grenada in 2000 to that in 2005?
Your answer should be very brief. 0.97. What is the ratio of the Debt(% of exports of goods, services and primary income) of Sri Lanka in 2000 to that in 2005?
Your answer should be compact. 2.51. What is the ratio of the Debt(% of exports of goods, services and primary income) in Cambodia in 2001 to that in 2002?
Provide a succinct answer. 1.02. What is the ratio of the Debt(% of exports of goods, services and primary income) in Grenada in 2001 to that in 2002?
Your answer should be very brief. 0.51. What is the ratio of the Debt(% of exports of goods, services and primary income) in Sri Lanka in 2001 to that in 2002?
Offer a terse response. 1.02. What is the ratio of the Debt(% of exports of goods, services and primary income) in Cambodia in 2001 to that in 2003?
Your answer should be compact. 0.91. What is the ratio of the Debt(% of exports of goods, services and primary income) in Grenada in 2001 to that in 2003?
Make the answer very short. 0.48. What is the ratio of the Debt(% of exports of goods, services and primary income) in Sri Lanka in 2001 to that in 2003?
Your answer should be very brief. 1.27. What is the ratio of the Debt(% of exports of goods, services and primary income) of Cambodia in 2001 to that in 2004?
Give a very brief answer. 1.07. What is the ratio of the Debt(% of exports of goods, services and primary income) in Grenada in 2001 to that in 2004?
Keep it short and to the point. 0.59. What is the ratio of the Debt(% of exports of goods, services and primary income) of Sri Lanka in 2001 to that in 2004?
Make the answer very short. 1.1. What is the ratio of the Debt(% of exports of goods, services and primary income) of Cambodia in 2001 to that in 2005?
Offer a very short reply. 1.18. What is the ratio of the Debt(% of exports of goods, services and primary income) of Grenada in 2001 to that in 2005?
Provide a short and direct response. 1.38. What is the ratio of the Debt(% of exports of goods, services and primary income) in Sri Lanka in 2001 to that in 2005?
Provide a short and direct response. 2.22. What is the ratio of the Debt(% of exports of goods, services and primary income) of Cambodia in 2002 to that in 2003?
Keep it short and to the point. 0.89. What is the ratio of the Debt(% of exports of goods, services and primary income) of Grenada in 2002 to that in 2003?
Give a very brief answer. 0.94. What is the ratio of the Debt(% of exports of goods, services and primary income) of Sri Lanka in 2002 to that in 2003?
Provide a succinct answer. 1.25. What is the ratio of the Debt(% of exports of goods, services and primary income) of Cambodia in 2002 to that in 2004?
Your answer should be compact. 1.06. What is the ratio of the Debt(% of exports of goods, services and primary income) of Grenada in 2002 to that in 2004?
Your answer should be compact. 1.15. What is the ratio of the Debt(% of exports of goods, services and primary income) of Sri Lanka in 2002 to that in 2004?
Your answer should be very brief. 1.08. What is the ratio of the Debt(% of exports of goods, services and primary income) in Cambodia in 2002 to that in 2005?
Make the answer very short. 1.16. What is the ratio of the Debt(% of exports of goods, services and primary income) in Grenada in 2002 to that in 2005?
Provide a short and direct response. 2.68. What is the ratio of the Debt(% of exports of goods, services and primary income) in Sri Lanka in 2002 to that in 2005?
Make the answer very short. 2.18. What is the ratio of the Debt(% of exports of goods, services and primary income) of Cambodia in 2003 to that in 2004?
Ensure brevity in your answer.  1.19. What is the ratio of the Debt(% of exports of goods, services and primary income) of Grenada in 2003 to that in 2004?
Provide a succinct answer. 1.22. What is the ratio of the Debt(% of exports of goods, services and primary income) of Sri Lanka in 2003 to that in 2004?
Your answer should be compact. 0.87. What is the ratio of the Debt(% of exports of goods, services and primary income) of Cambodia in 2003 to that in 2005?
Keep it short and to the point. 1.31. What is the ratio of the Debt(% of exports of goods, services and primary income) of Grenada in 2003 to that in 2005?
Ensure brevity in your answer.  2.86. What is the ratio of the Debt(% of exports of goods, services and primary income) in Sri Lanka in 2003 to that in 2005?
Keep it short and to the point. 1.75. What is the ratio of the Debt(% of exports of goods, services and primary income) of Cambodia in 2004 to that in 2005?
Offer a terse response. 1.1. What is the ratio of the Debt(% of exports of goods, services and primary income) in Grenada in 2004 to that in 2005?
Provide a succinct answer. 2.34. What is the ratio of the Debt(% of exports of goods, services and primary income) of Sri Lanka in 2004 to that in 2005?
Keep it short and to the point. 2.01. What is the difference between the highest and the second highest Debt(% of exports of goods, services and primary income) in Cambodia?
Make the answer very short. 0.71. What is the difference between the highest and the second highest Debt(% of exports of goods, services and primary income) of Grenada?
Your answer should be compact. 1.03. What is the difference between the highest and the second highest Debt(% of exports of goods, services and primary income) of Sri Lanka?
Ensure brevity in your answer.  0.87. What is the difference between the highest and the lowest Debt(% of exports of goods, services and primary income) of Cambodia?
Ensure brevity in your answer.  1.42. What is the difference between the highest and the lowest Debt(% of exports of goods, services and primary income) of Grenada?
Keep it short and to the point. 12.19. What is the difference between the highest and the lowest Debt(% of exports of goods, services and primary income) of Sri Lanka?
Provide a short and direct response. 7.39. 